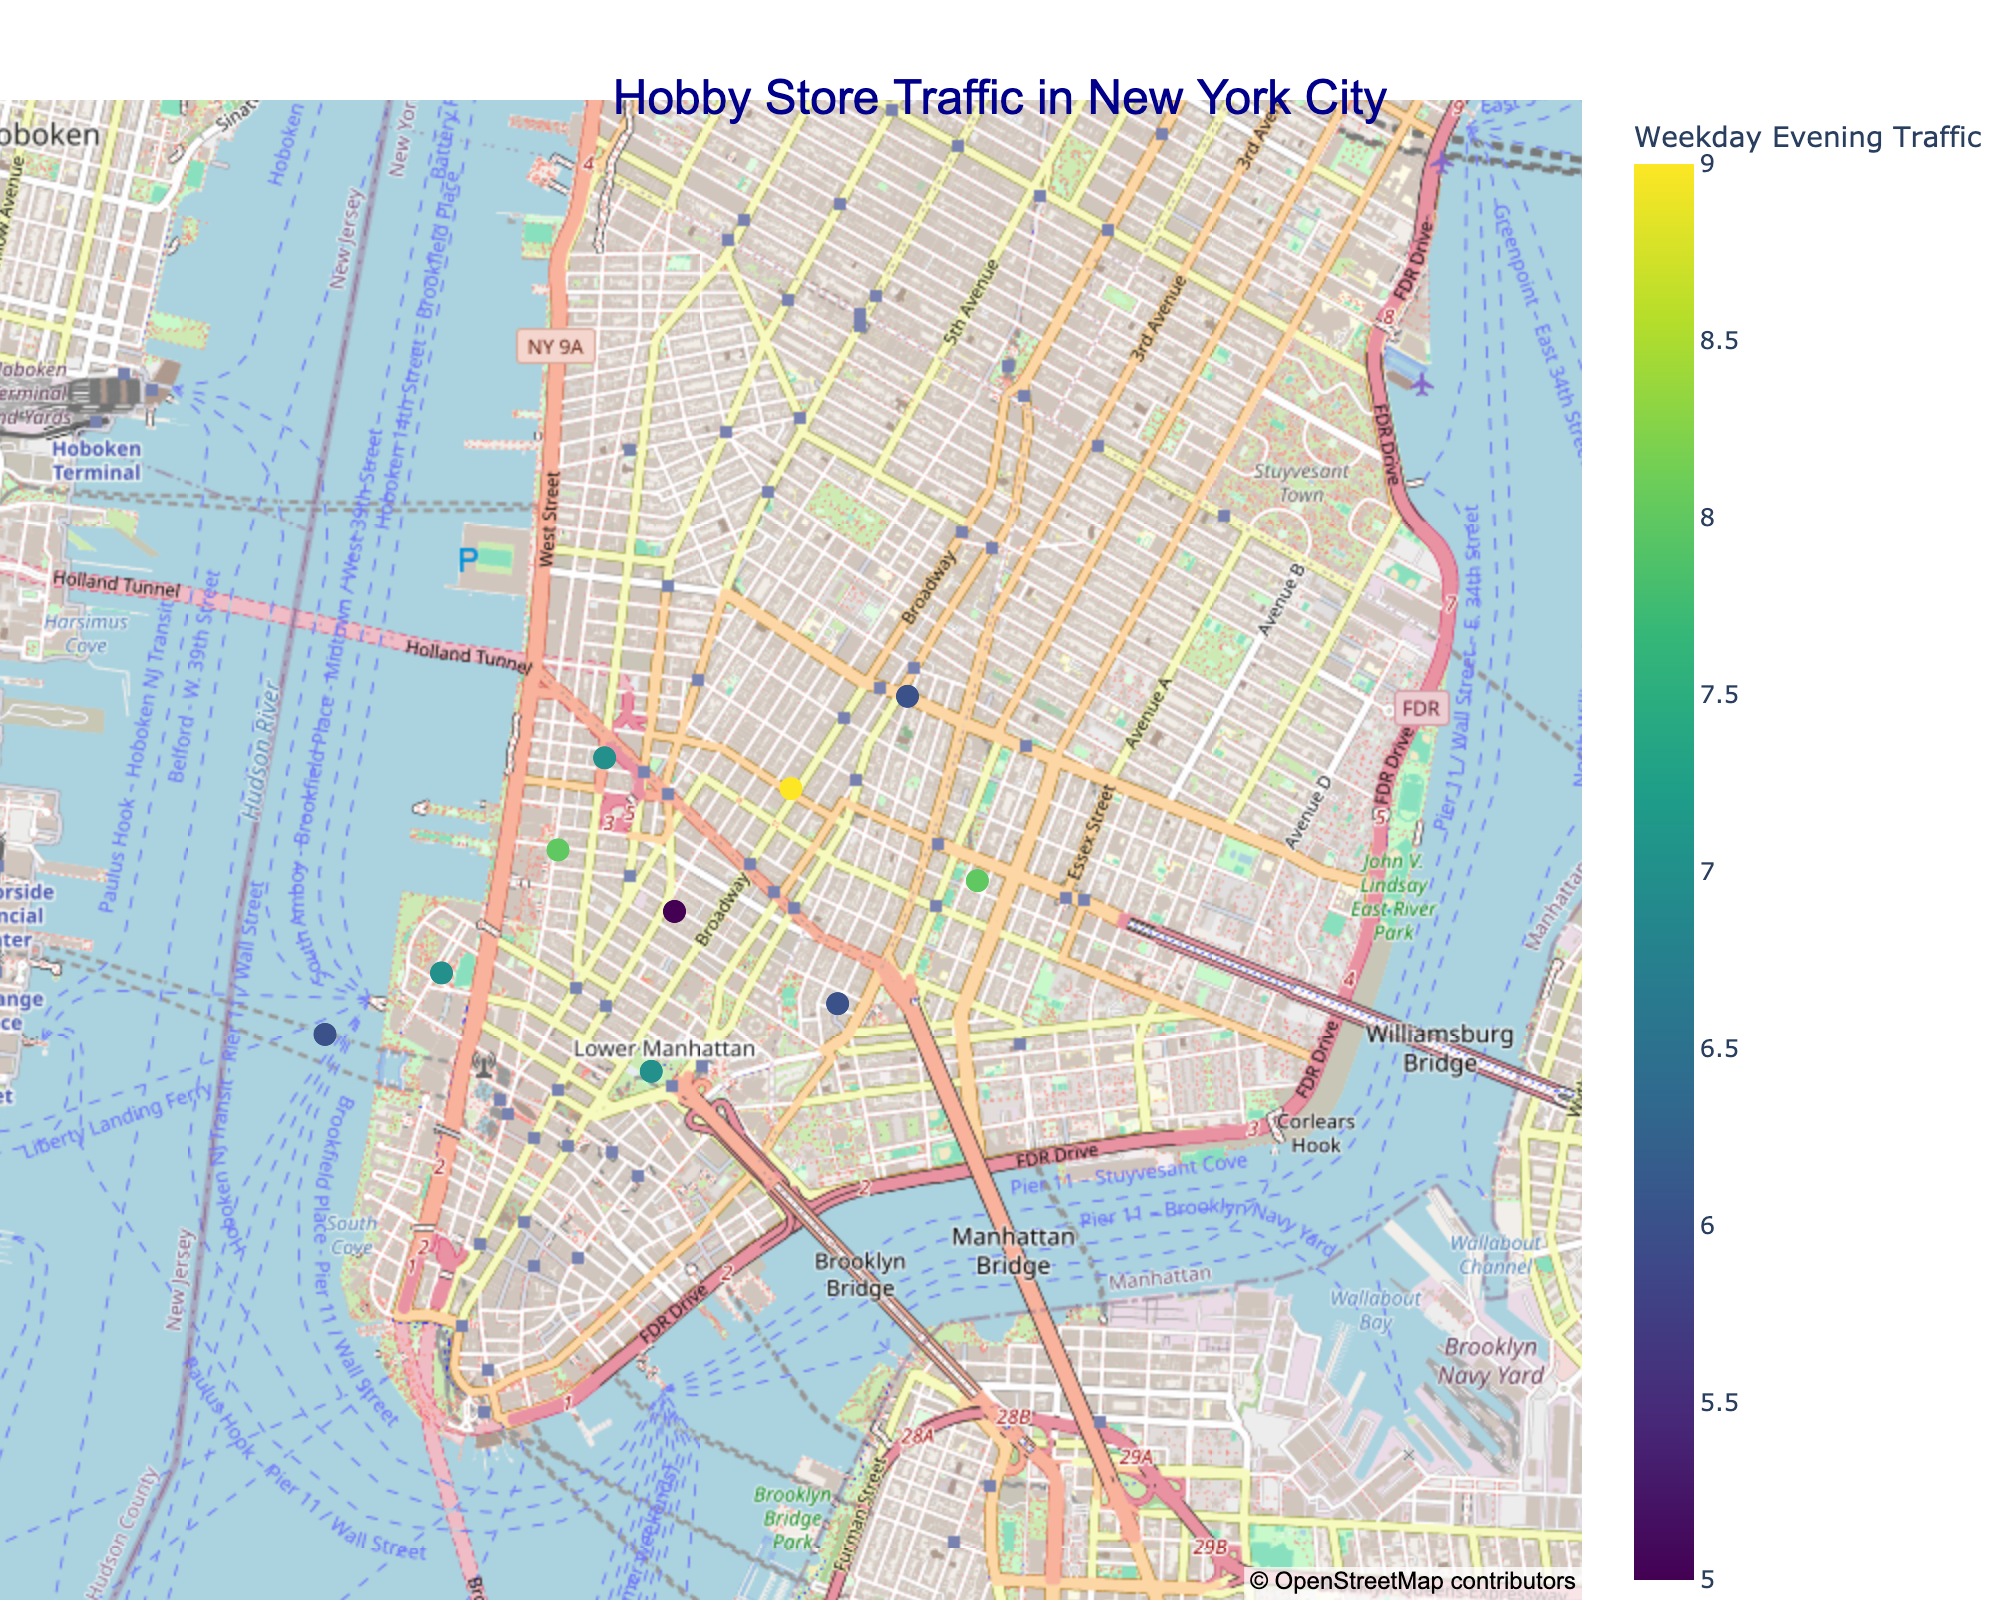What's the title of the figure? The title is usually displayed prominently on the top of the figure. Here, it reads "Hobby Store Traffic in New York City".
Answer: Hobby Store Traffic in New York City How many hobby stores are shown in the figure? Count the markers representing stores on the map. There should be one marker for each store in the data.
Answer: 10 Which store has the highest weekday evening traffic? Identify the marker with the highest color intensity and cross-reference with the store names in the data.
Answer: Board Game Bonanza What is the traffic pattern difference between weekday evenings and weekends for Craft Corner? Look for Craft Corner's traffic values in both categories and subtract the weekday evening value from the weekend value (8 - 6).
Answer: 2 Which store has the smallest difference between weekday evening and weekend traffic? Calculate the differences for each store and identify the smallest value. Puzzle Palace has weekday traffic of 7 and weekend traffic of 8, resulting in a difference of 1.
Answer: Puzzle Palace How does the traffic compare between Hobby Haven and RC Racers on weekends? Look at the annotations near the markers for both stores indicating weekend traffic. Compare the values (Hobby Haven: 9, RC Racers: 9).
Answer: Equal Which store is positioned the furthest west on the map? Look at the longitude coordinates of the markers and identify which has the smallest (most negative) value.
Answer: Puzzle Palace What is the average weekend traffic for all stores? Sum the weekend traffic values for all stores and divide by the number of stores ((9 + 8 + 10 + 7 + 9 + 8 + 10 + 9 + 8 + 9) / 10).
Answer: 8.7 Are there any stores with identical weekday evening traffic values? Check if multiple stores have the same weekday evening traffic value. Hobby Haven, Puzzle Palace, and Art Supply Depot all have a value of 7.
Answer: Yes Which store has the highest combined weekday evening and weekend traffic? Sum the two traffic values for each store, and identify the highest. Board Game Bonanza has combined traffic of 19 (9 weekday + 10 weekend).
Answer: Board Game Bonanza 